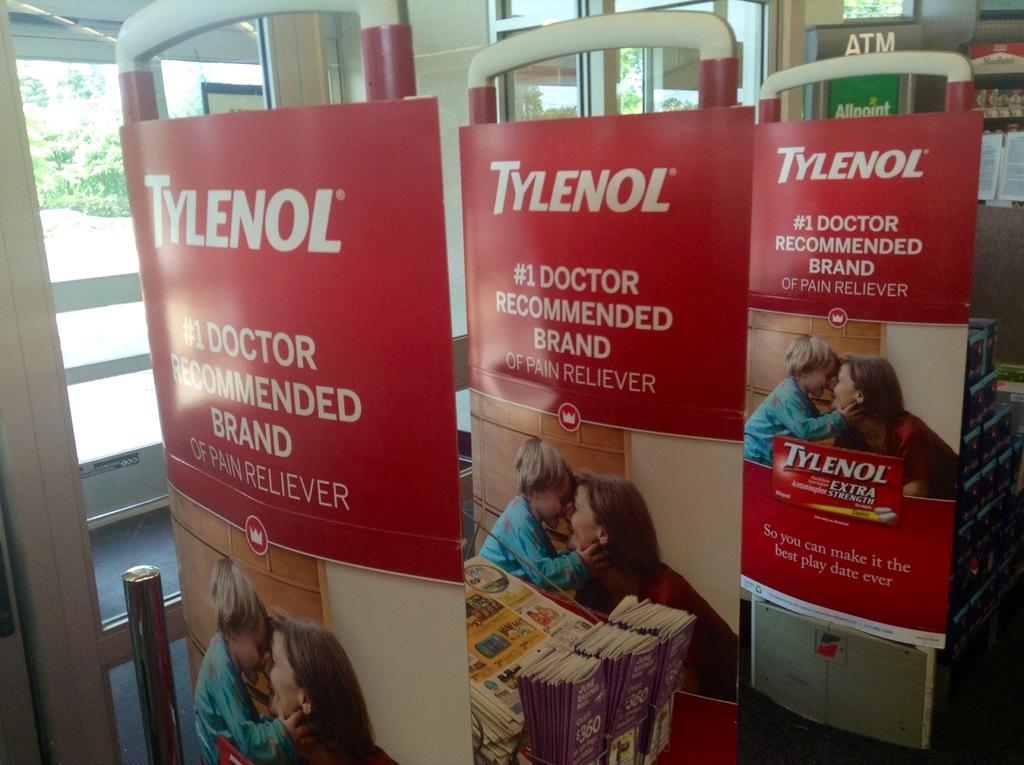What brand is #1 doctor recommended?
Make the answer very short. Tylenol. What is tylenol used for?
Provide a succinct answer. Pain reliever. 